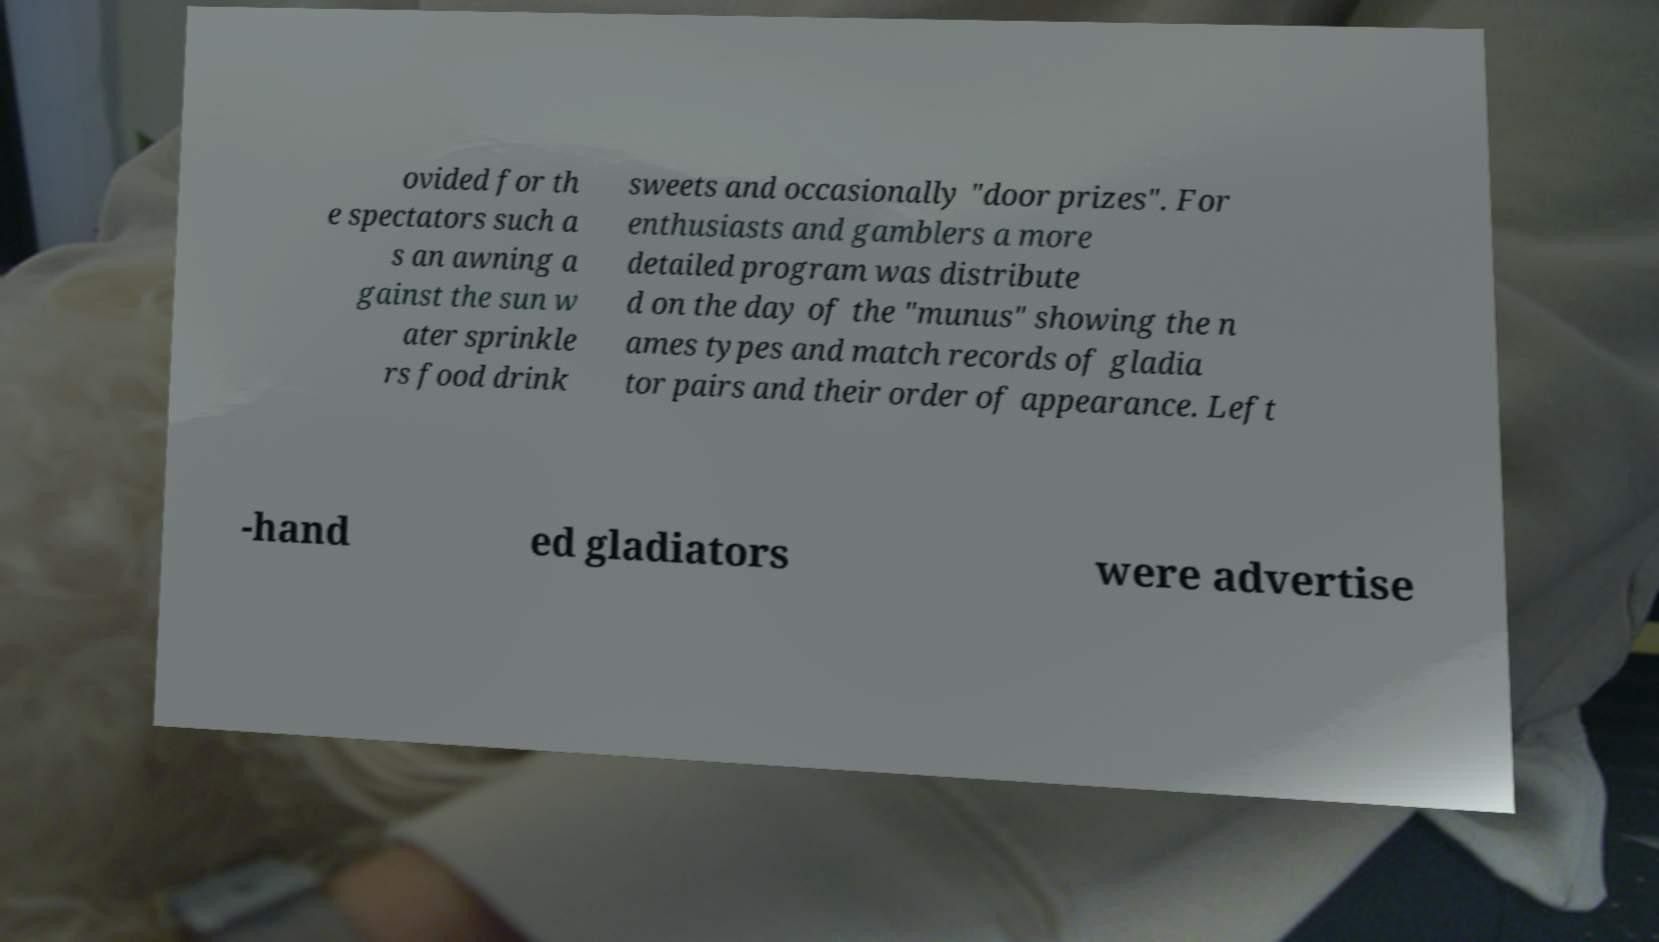What messages or text are displayed in this image? I need them in a readable, typed format. ovided for th e spectators such a s an awning a gainst the sun w ater sprinkle rs food drink sweets and occasionally "door prizes". For enthusiasts and gamblers a more detailed program was distribute d on the day of the "munus" showing the n ames types and match records of gladia tor pairs and their order of appearance. Left -hand ed gladiators were advertise 